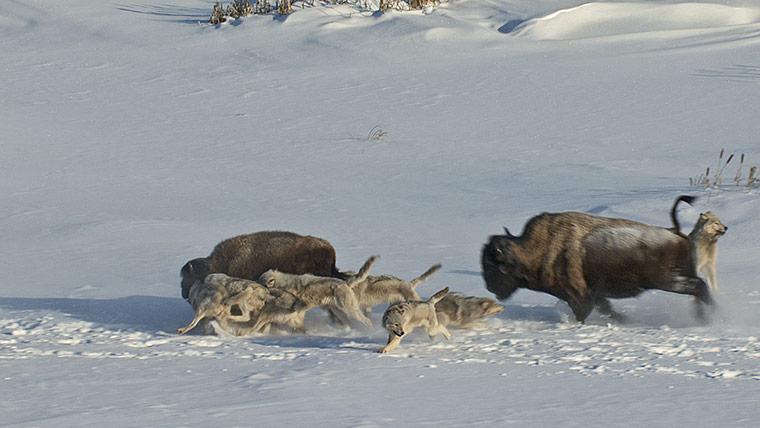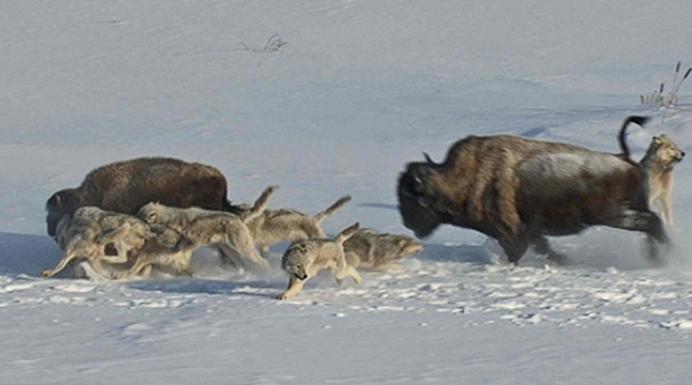The first image is the image on the left, the second image is the image on the right. Evaluate the accuracy of this statement regarding the images: "wolves are feasting on a carcass". Is it true? Answer yes or no. No. 